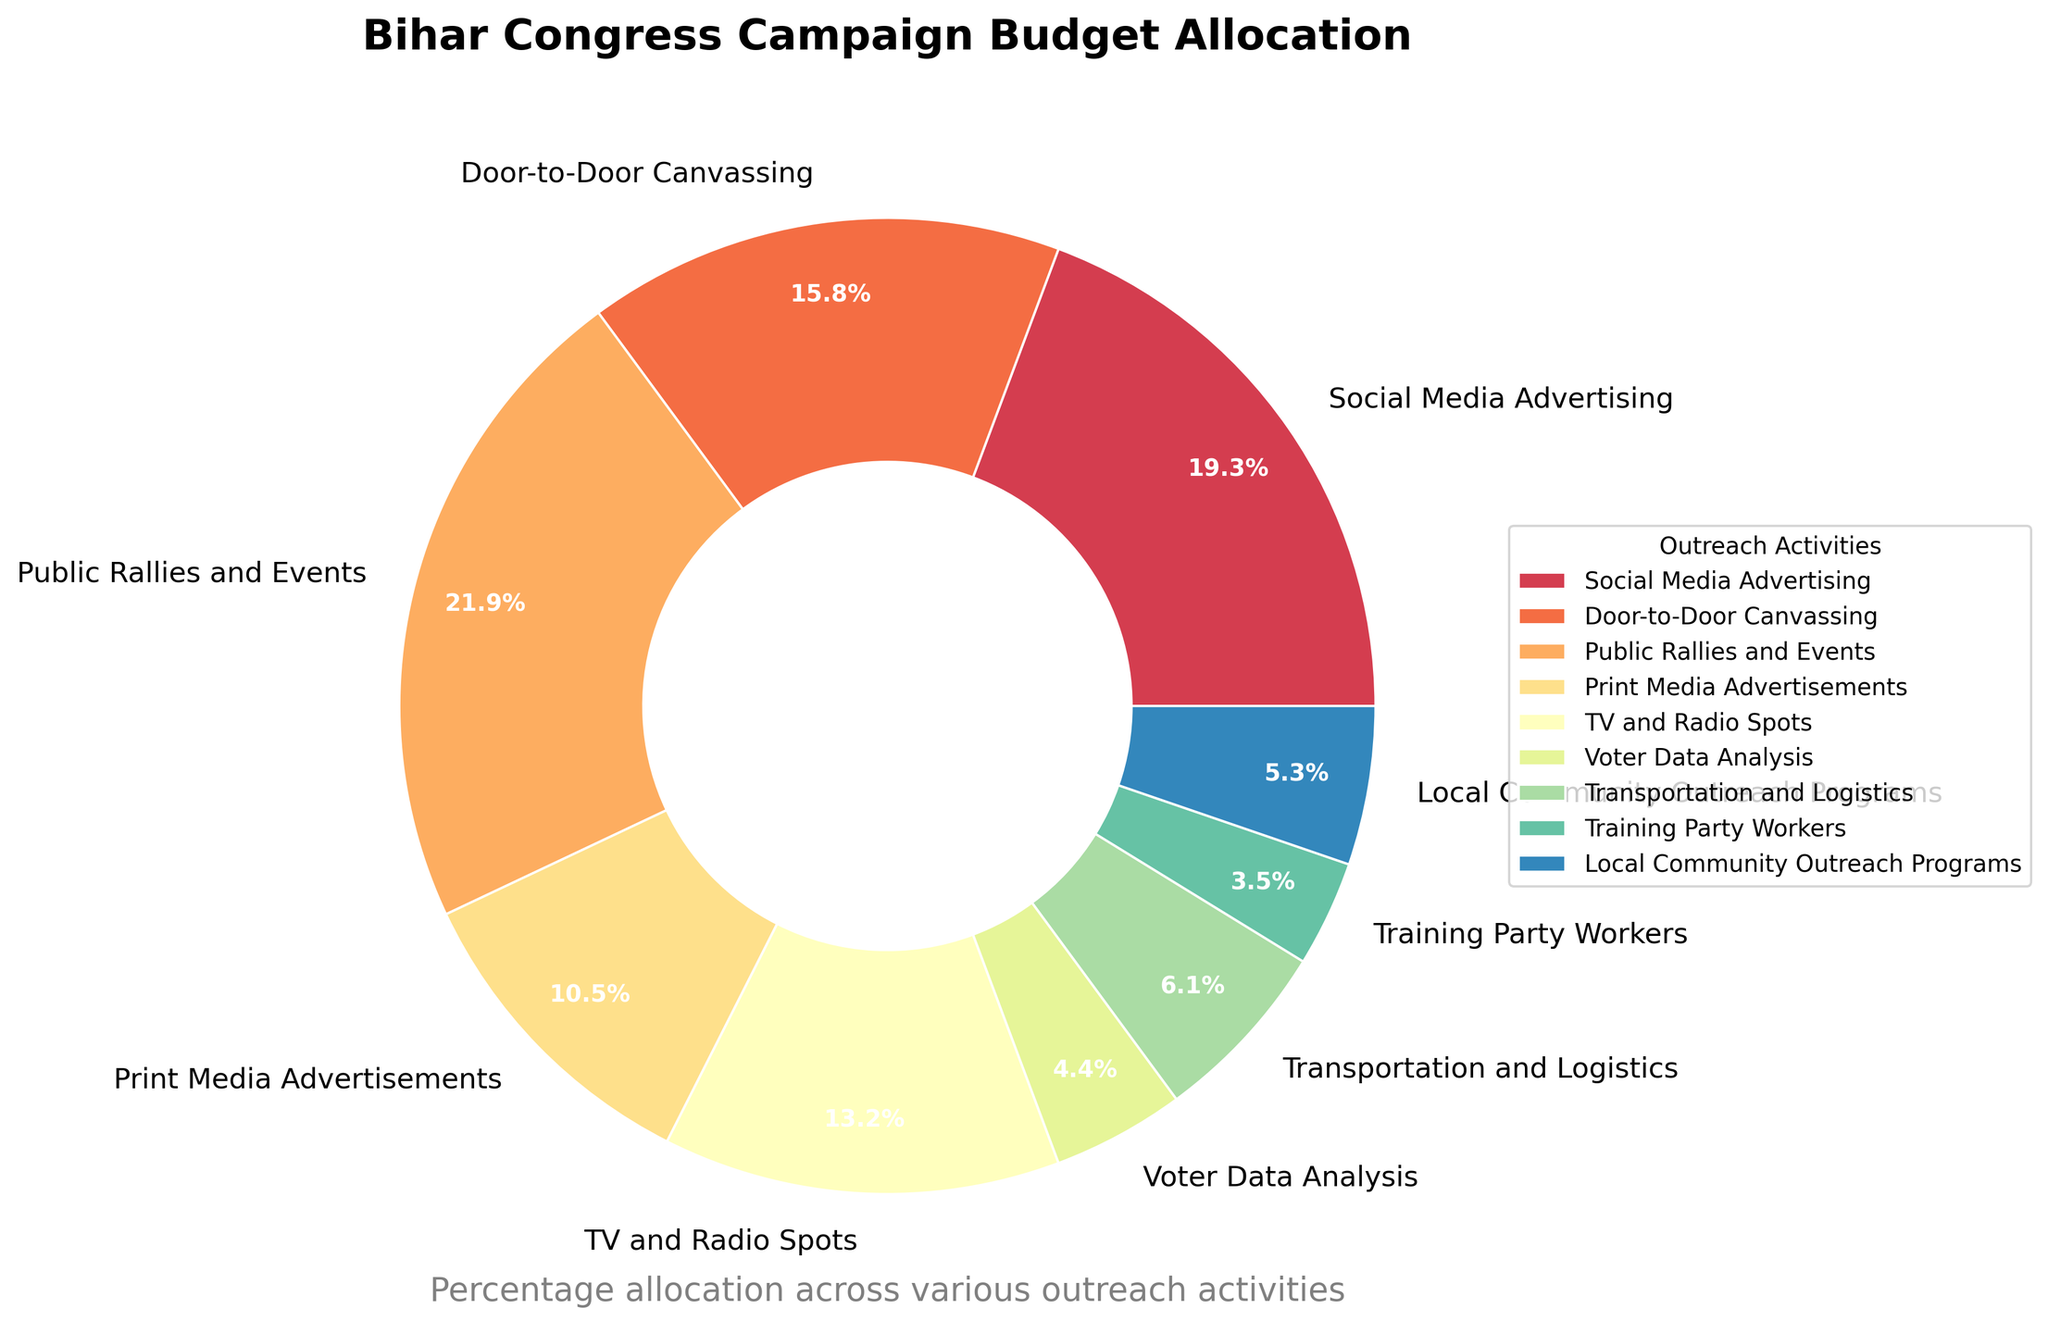What is the largest allocation of the Bihar Congress campaign budget? The largest allocation is represented by the largest wedge in the pie chart. By looking at the sizes of the wedges, we see that 'Public Rallies and Events' has the largest portion. The percentage value shown for this category, 25%, confirms it.
Answer: Public Rallies and Events How much more percentage is allocated to Social Media Advertising compared to Voter Data Analysis? First, identify the percentage for Social Media Advertising (22%) and Voter Data Analysis (5%). Then, subtract the Voter Data Analysis percentage from the Social Media Advertising percentage: 22 - 5 = 17%.
Answer: 17% Which two activities have the smallest budget allocation, and what are their combined percentage? Look at the pie chart to identify the smallest wedges. 'Training Party Workers' (4%) and 'Voter Data Analysis' (5%) have the smallest slices. Adding their percentages: 4% + 5% = 9%.
Answer: Training Party Workers and Voter Data Analysis, 9% What is the sum of the budget percentages allocated to Door-to-Door Canvassing and Print Media Advertisements? Identify the percentages allocated to Door-to-Door Canvassing (18%) and Print Media Advertisements (12%). Then, add these two values together: 18% + 12% = 30%.
Answer: 30% Which activity has a larger budget allocation: Transportation and Logistics or Local Community Outreach Programs? By how much? Find the percentages for both activities. Transportation and Logistics is 7%, and Local Community Outreach Programs is 6%. Subtract the smaller percentage from the larger one: 7% - 6% = 1%.
Answer: Transportation and Logistics, 1% Is the percentage allocated to TV and Radio Spots greater than or equal to the percentage allocated to Print Media Advertisements? Compare the percentages for TV and Radio Spots (15%) and Print Media Advertisements (12%). Since 15 is greater than 12, yes, TV and Radio Spots allocation is greater.
Answer: Yes What is the difference in the budget allocation between the activity with the highest percentage and the activity with the lowest percentage? Identify the highest percentage (Public Rallies and Events, 25%) and the lowest percentage (Training Party Workers, 4%). Subtract the lowest percentage from the highest: 25% - 4% = 21%.
Answer: 21% How many activities have an allocation of 10% or more? Count the wedges in the pie chart with budget percentages of 10% or more: Social Media Advertising (22%), Door-to-Door Canvassing (18%), Public Rallies and Events (25%), Print Media Advertisements (12%), and TV and Radio Spots (15%). This gives us a total of 5 activities.
Answer: 5 What percentage of the budget is allocated to activities other than Public Rallies and Events? Subtract the percentage allocated to Public Rallies and Events (25%) from the total budget (100%): 100% - 25% = 75%.
Answer: 75% What is the average budget allocation for Social Media Advertising, Door-to-Door Canvassing, and TV and Radio Spots? Identify the percentages for Social Media Advertising (22%), Door-to-Door Canvassing (18%), and TV and Radio Spots (15%). Add these percentages together and then divide by the number of activities: (22 + 18 + 15) / 3 = 55 / 3 ≈ 18.33%.
Answer: 18.33% 